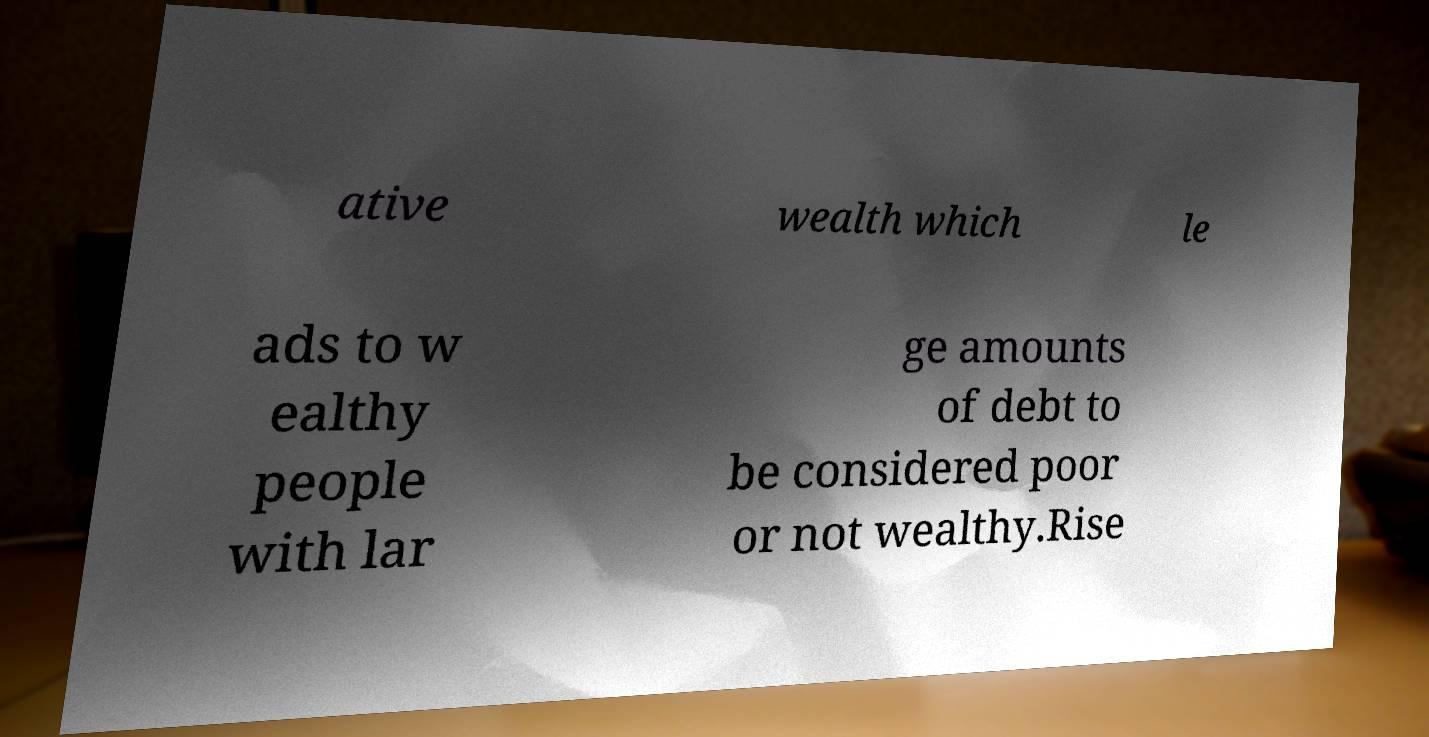Can you read and provide the text displayed in the image?This photo seems to have some interesting text. Can you extract and type it out for me? ative wealth which le ads to w ealthy people with lar ge amounts of debt to be considered poor or not wealthy.Rise 